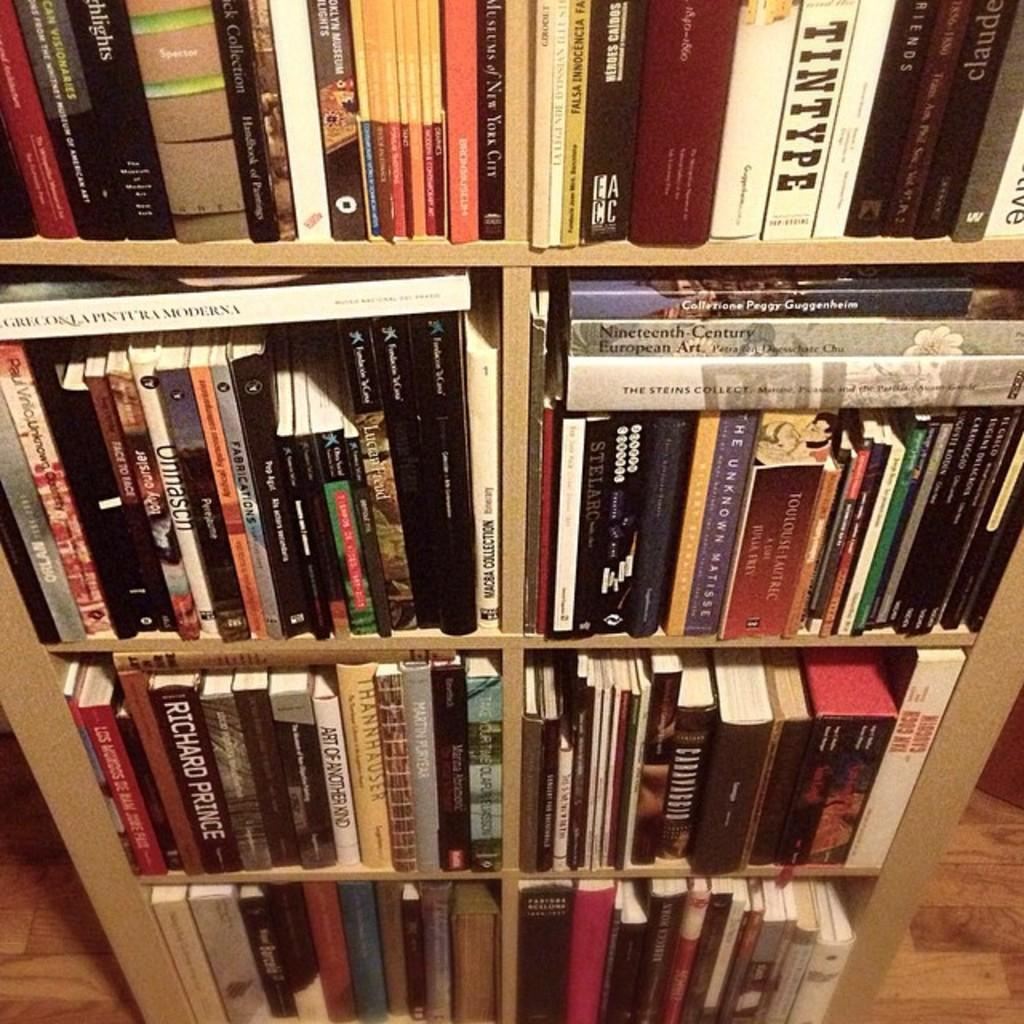<image>
Offer a succinct explanation of the picture presented. Shelf full of books including one written by Richard Prince. 